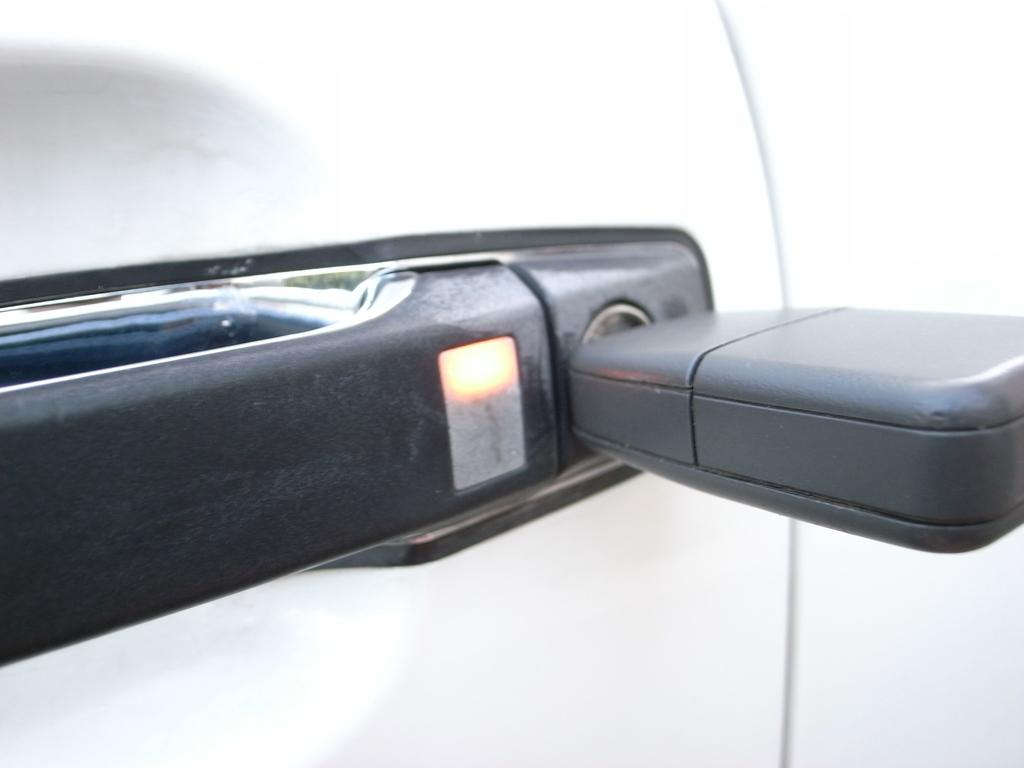What object can be seen on the door in the image? There is a door handle in the image. What riddle is hidden behind the door handle in the image? There is no riddle hidden behind the door handle in the image; it is simply a door handle. 